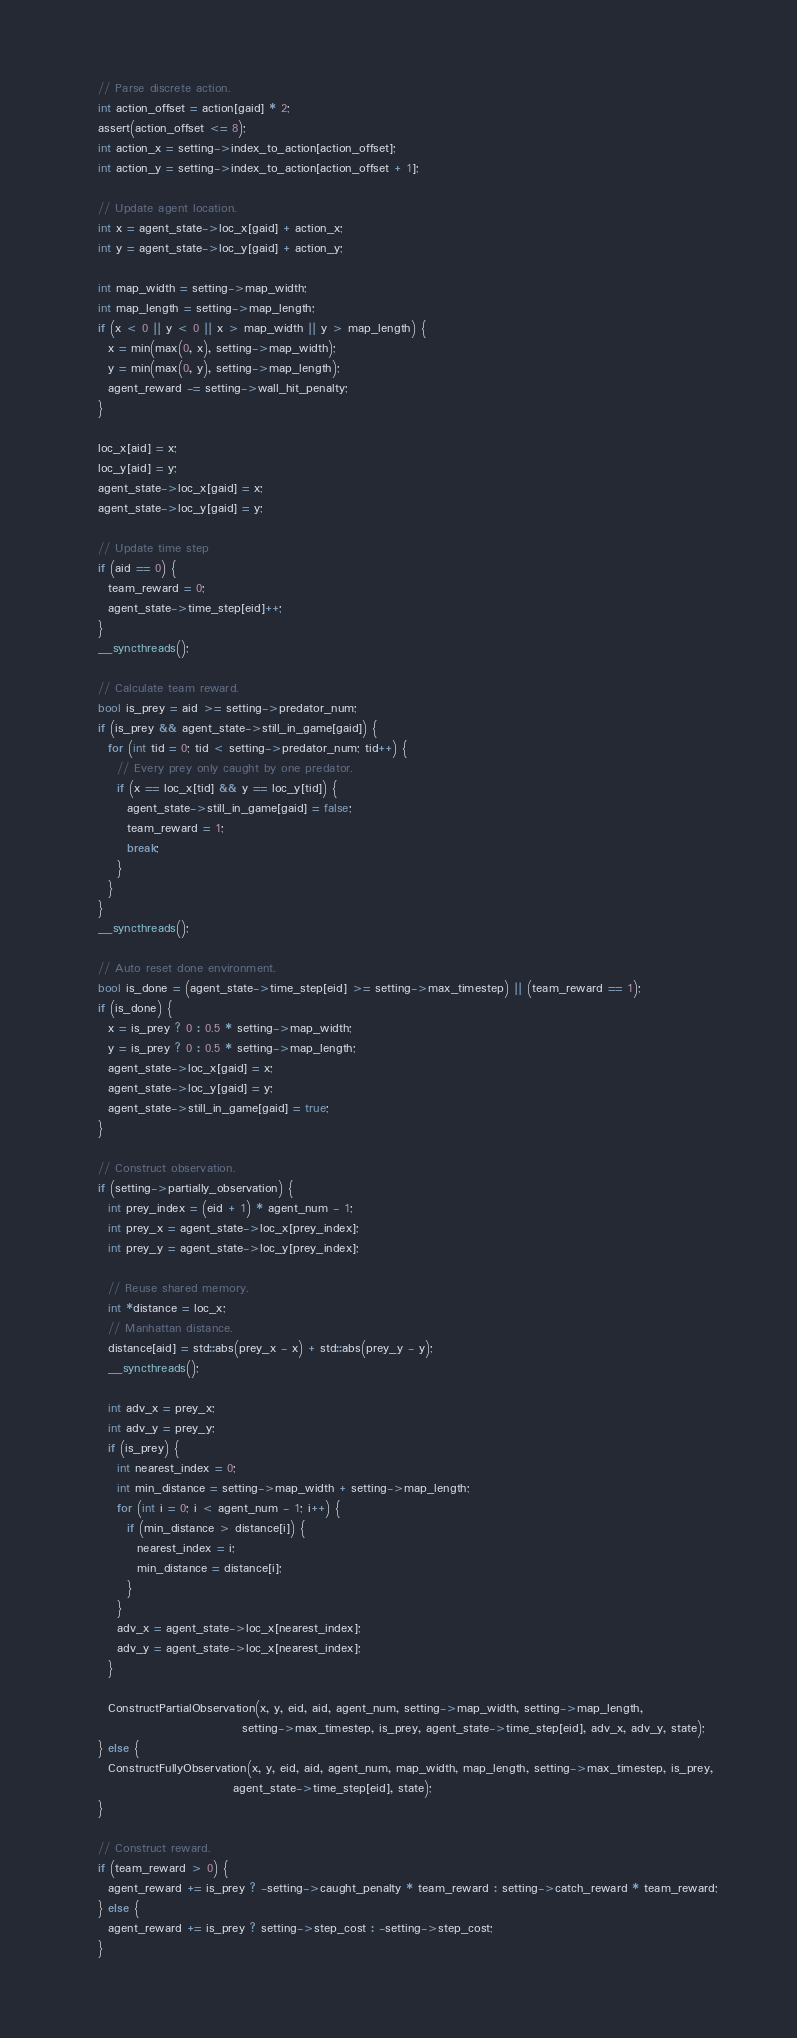Convert code to text. <code><loc_0><loc_0><loc_500><loc_500><_Cuda_>
    // Parse discrete action.
    int action_offset = action[gaid] * 2;
    assert(action_offset <= 8);
    int action_x = setting->index_to_action[action_offset];
    int action_y = setting->index_to_action[action_offset + 1];

    // Update agent location.
    int x = agent_state->loc_x[gaid] + action_x;
    int y = agent_state->loc_y[gaid] + action_y;

    int map_width = setting->map_width;
    int map_length = setting->map_length;
    if (x < 0 || y < 0 || x > map_width || y > map_length) {
      x = min(max(0, x), setting->map_width);
      y = min(max(0, y), setting->map_length);
      agent_reward -= setting->wall_hit_penalty;
    }

    loc_x[aid] = x;
    loc_y[aid] = y;
    agent_state->loc_x[gaid] = x;
    agent_state->loc_y[gaid] = y;

    // Update time step
    if (aid == 0) {
      team_reward = 0;
      agent_state->time_step[eid]++;
    }
    __syncthreads();

    // Calculate team reward.
    bool is_prey = aid >= setting->predator_num;
    if (is_prey && agent_state->still_in_game[gaid]) {
      for (int tid = 0; tid < setting->predator_num; tid++) {
        // Every prey only caught by one predator.
        if (x == loc_x[tid] && y == loc_y[tid]) {
          agent_state->still_in_game[gaid] = false;
          team_reward = 1;
          break;
        }
      }
    }
    __syncthreads();

    // Auto reset done environment.
    bool is_done = (agent_state->time_step[eid] >= setting->max_timestep) || (team_reward == 1);
    if (is_done) {
      x = is_prey ? 0 : 0.5 * setting->map_width;
      y = is_prey ? 0 : 0.5 * setting->map_length;
      agent_state->loc_x[gaid] = x;
      agent_state->loc_y[gaid] = y;
      agent_state->still_in_game[gaid] = true;
    }

    // Construct observation.
    if (setting->partially_observation) {
      int prey_index = (eid + 1) * agent_num - 1;
      int prey_x = agent_state->loc_x[prey_index];
      int prey_y = agent_state->loc_y[prey_index];

      // Reuse shared memory.
      int *distance = loc_x;
      // Manhattan distance.
      distance[aid] = std::abs(prey_x - x) + std::abs(prey_y - y);
      __syncthreads();

      int adv_x = prey_x;
      int adv_y = prey_y;
      if (is_prey) {
        int nearest_index = 0;
        int min_distance = setting->map_width + setting->map_length;
        for (int i = 0; i < agent_num - 1; i++) {
          if (min_distance > distance[i]) {
            nearest_index = i;
            min_distance = distance[i];
          }
        }
        adv_x = agent_state->loc_x[nearest_index];
        adv_y = agent_state->loc_x[nearest_index];
      }

      ConstructPartialObservation(x, y, eid, aid, agent_num, setting->map_width, setting->map_length,
                                  setting->max_timestep, is_prey, agent_state->time_step[eid], adv_x, adv_y, state);
    } else {
      ConstructFullyObservation(x, y, eid, aid, agent_num, map_width, map_length, setting->max_timestep, is_prey,
                                agent_state->time_step[eid], state);
    }

    // Construct reward.
    if (team_reward > 0) {
      agent_reward += is_prey ? -setting->caught_penalty * team_reward : setting->catch_reward * team_reward;
    } else {
      agent_reward += is_prey ? setting->step_cost : -setting->step_cost;
    }</code> 